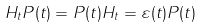<formula> <loc_0><loc_0><loc_500><loc_500>H _ { t } P ( t ) = P ( t ) H _ { t } = \varepsilon ( t ) P ( t )</formula> 